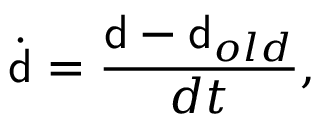Convert formula to latex. <formula><loc_0><loc_0><loc_500><loc_500>\dot { d } = \frac { { d } - { d } _ { o l d } } { d t } ,</formula> 